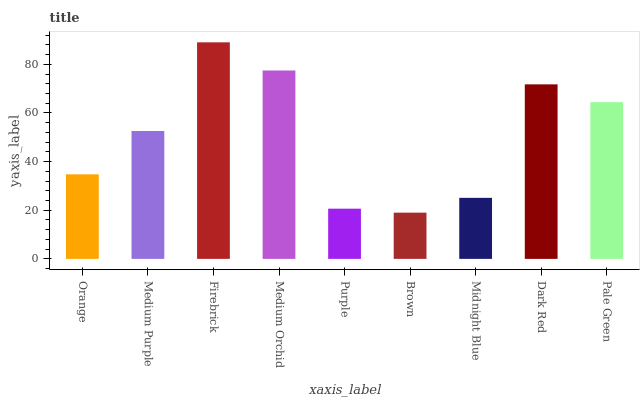Is Brown the minimum?
Answer yes or no. Yes. Is Firebrick the maximum?
Answer yes or no. Yes. Is Medium Purple the minimum?
Answer yes or no. No. Is Medium Purple the maximum?
Answer yes or no. No. Is Medium Purple greater than Orange?
Answer yes or no. Yes. Is Orange less than Medium Purple?
Answer yes or no. Yes. Is Orange greater than Medium Purple?
Answer yes or no. No. Is Medium Purple less than Orange?
Answer yes or no. No. Is Medium Purple the high median?
Answer yes or no. Yes. Is Medium Purple the low median?
Answer yes or no. Yes. Is Firebrick the high median?
Answer yes or no. No. Is Pale Green the low median?
Answer yes or no. No. 